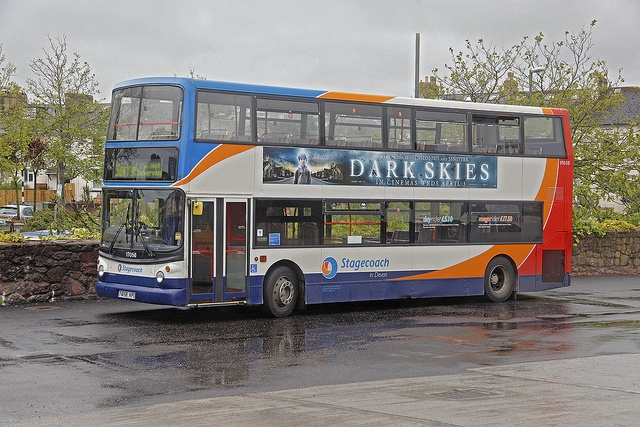Describe the objects in this image and their specific colors. I can see bus in darkgray, gray, black, and lightgray tones and car in darkgray, gray, lightgray, and black tones in this image. 